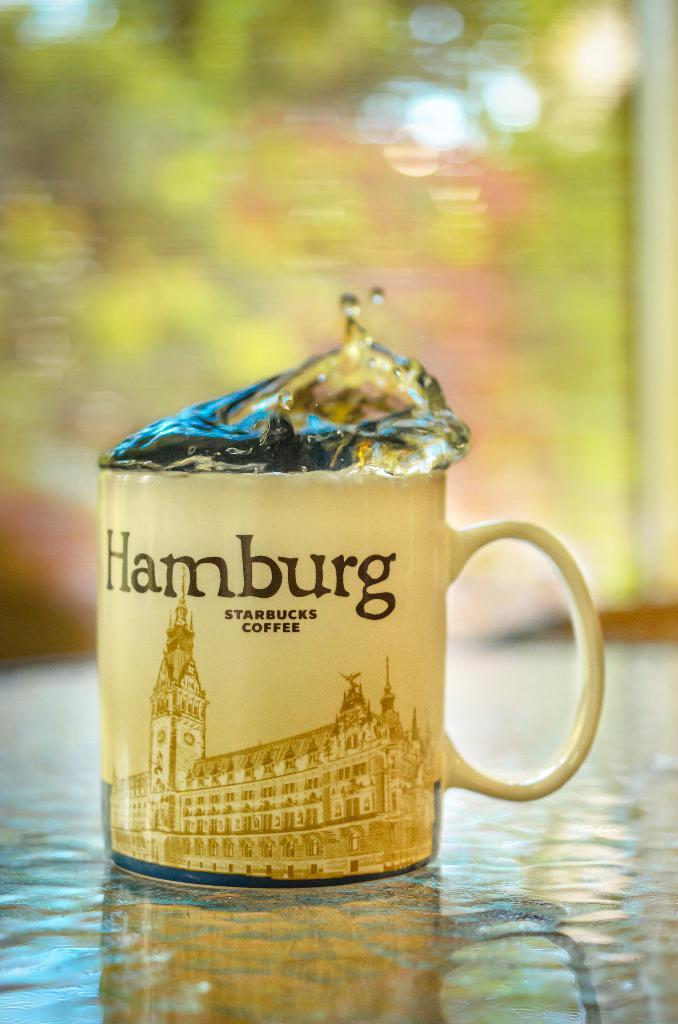<image>
Write a terse but informative summary of the picture. A coffee mug with liquid coming out of it that says Hamburg Starbucks Coffee on it. 